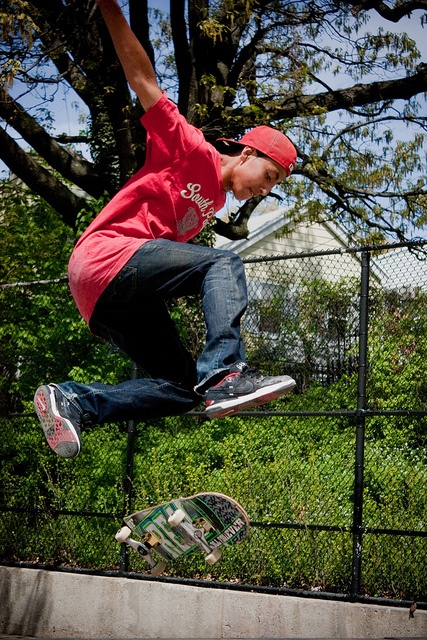Describe the objects in this image and their specific colors. I can see people in black, brown, maroon, and gray tones and skateboard in black, gray, darkgray, and darkgreen tones in this image. 